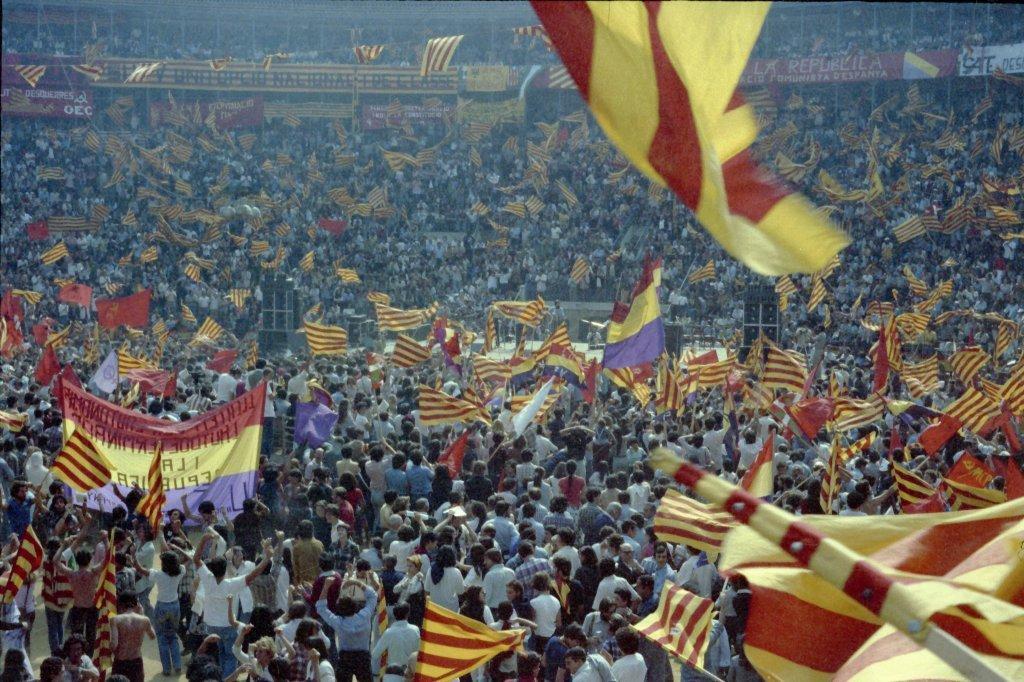Could you give a brief overview of what you see in this image? In this image there are people standing and waving flags. 